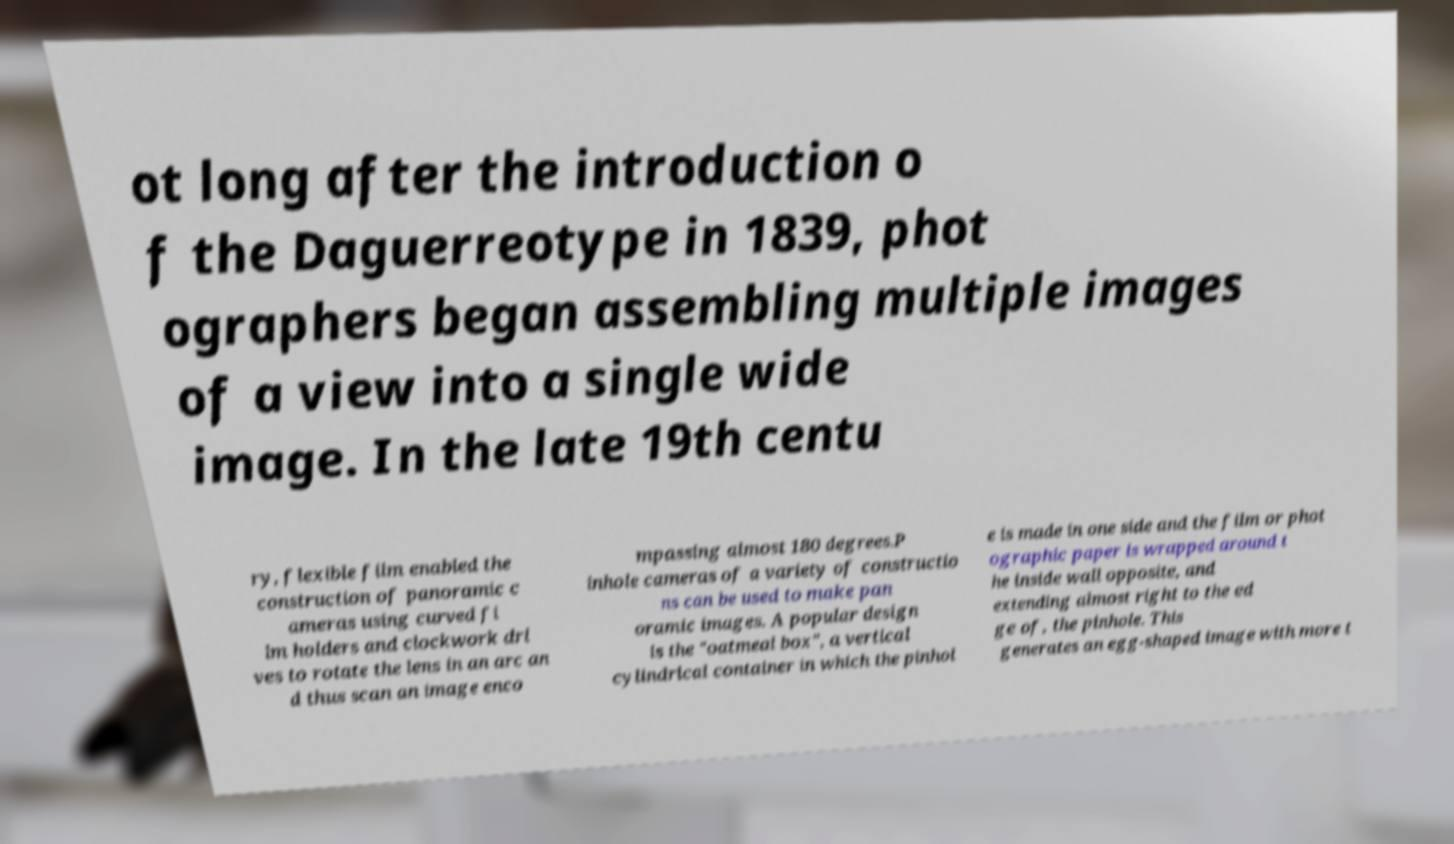For documentation purposes, I need the text within this image transcribed. Could you provide that? ot long after the introduction o f the Daguerreotype in 1839, phot ographers began assembling multiple images of a view into a single wide image. In the late 19th centu ry, flexible film enabled the construction of panoramic c ameras using curved fi lm holders and clockwork dri ves to rotate the lens in an arc an d thus scan an image enco mpassing almost 180 degrees.P inhole cameras of a variety of constructio ns can be used to make pan oramic images. A popular design is the "oatmeal box", a vertical cylindrical container in which the pinhol e is made in one side and the film or phot ographic paper is wrapped around t he inside wall opposite, and extending almost right to the ed ge of, the pinhole. This generates an egg-shaped image with more t 